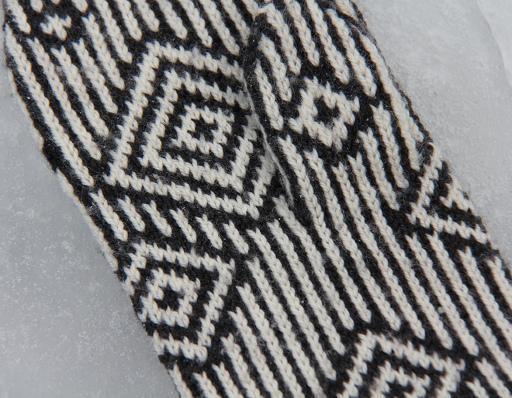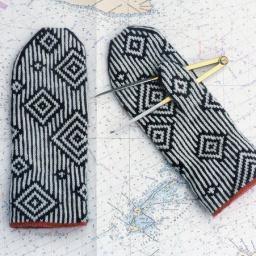The first image is the image on the left, the second image is the image on the right. Examine the images to the left and right. Is the description "An image shows a pair of mittens featuring a pattern of vertical stripes and concentric diamonds." accurate? Answer yes or no. Yes. The first image is the image on the left, the second image is the image on the right. For the images shown, is this caption "Only one mitten is shown in the image on the left." true? Answer yes or no. Yes. 